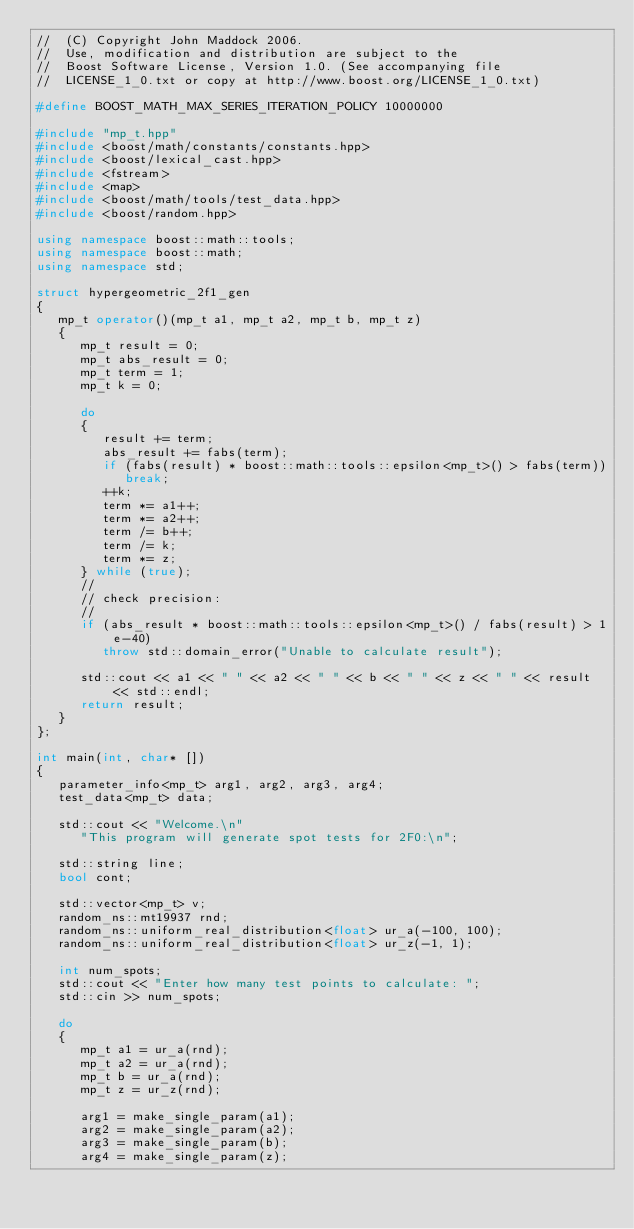Convert code to text. <code><loc_0><loc_0><loc_500><loc_500><_C++_>//  (C) Copyright John Maddock 2006.
//  Use, modification and distribution are subject to the
//  Boost Software License, Version 1.0. (See accompanying file
//  LICENSE_1_0.txt or copy at http://www.boost.org/LICENSE_1_0.txt)

#define BOOST_MATH_MAX_SERIES_ITERATION_POLICY 10000000

#include "mp_t.hpp"
#include <boost/math/constants/constants.hpp>
#include <boost/lexical_cast.hpp>
#include <fstream>
#include <map>
#include <boost/math/tools/test_data.hpp>
#include <boost/random.hpp>

using namespace boost::math::tools;
using namespace boost::math;
using namespace std;

struct hypergeometric_2f1_gen
{
   mp_t operator()(mp_t a1, mp_t a2, mp_t b, mp_t z)
   {
      mp_t result = 0;
      mp_t abs_result = 0;
      mp_t term = 1;
      mp_t k = 0;

      do
      {
         result += term;
         abs_result += fabs(term);
         if (fabs(result) * boost::math::tools::epsilon<mp_t>() > fabs(term))
            break;
         ++k;
         term *= a1++;
         term *= a2++;
         term /= b++;
         term /= k;
         term *= z;
      } while (true);
      //
      // check precision:
      //
      if (abs_result * boost::math::tools::epsilon<mp_t>() / fabs(result) > 1e-40)
         throw std::domain_error("Unable to calculate result");

      std::cout << a1 << " " << a2 << " " << b << " " << z << " " << result << std::endl;
      return result;
   }
};

int main(int, char* [])
{
   parameter_info<mp_t> arg1, arg2, arg3, arg4;
   test_data<mp_t> data;

   std::cout << "Welcome.\n"
      "This program will generate spot tests for 2F0:\n";

   std::string line;
   bool cont;

   std::vector<mp_t> v;
   random_ns::mt19937 rnd;
   random_ns::uniform_real_distribution<float> ur_a(-100, 100);
   random_ns::uniform_real_distribution<float> ur_z(-1, 1);

   int num_spots;
   std::cout << "Enter how many test points to calculate: ";
   std::cin >> num_spots;

   do
   {
      mp_t a1 = ur_a(rnd);
      mp_t a2 = ur_a(rnd);
      mp_t b = ur_a(rnd);
      mp_t z = ur_z(rnd);

      arg1 = make_single_param(a1);
      arg2 = make_single_param(a2);
      arg3 = make_single_param(b);
      arg4 = make_single_param(z);</code> 